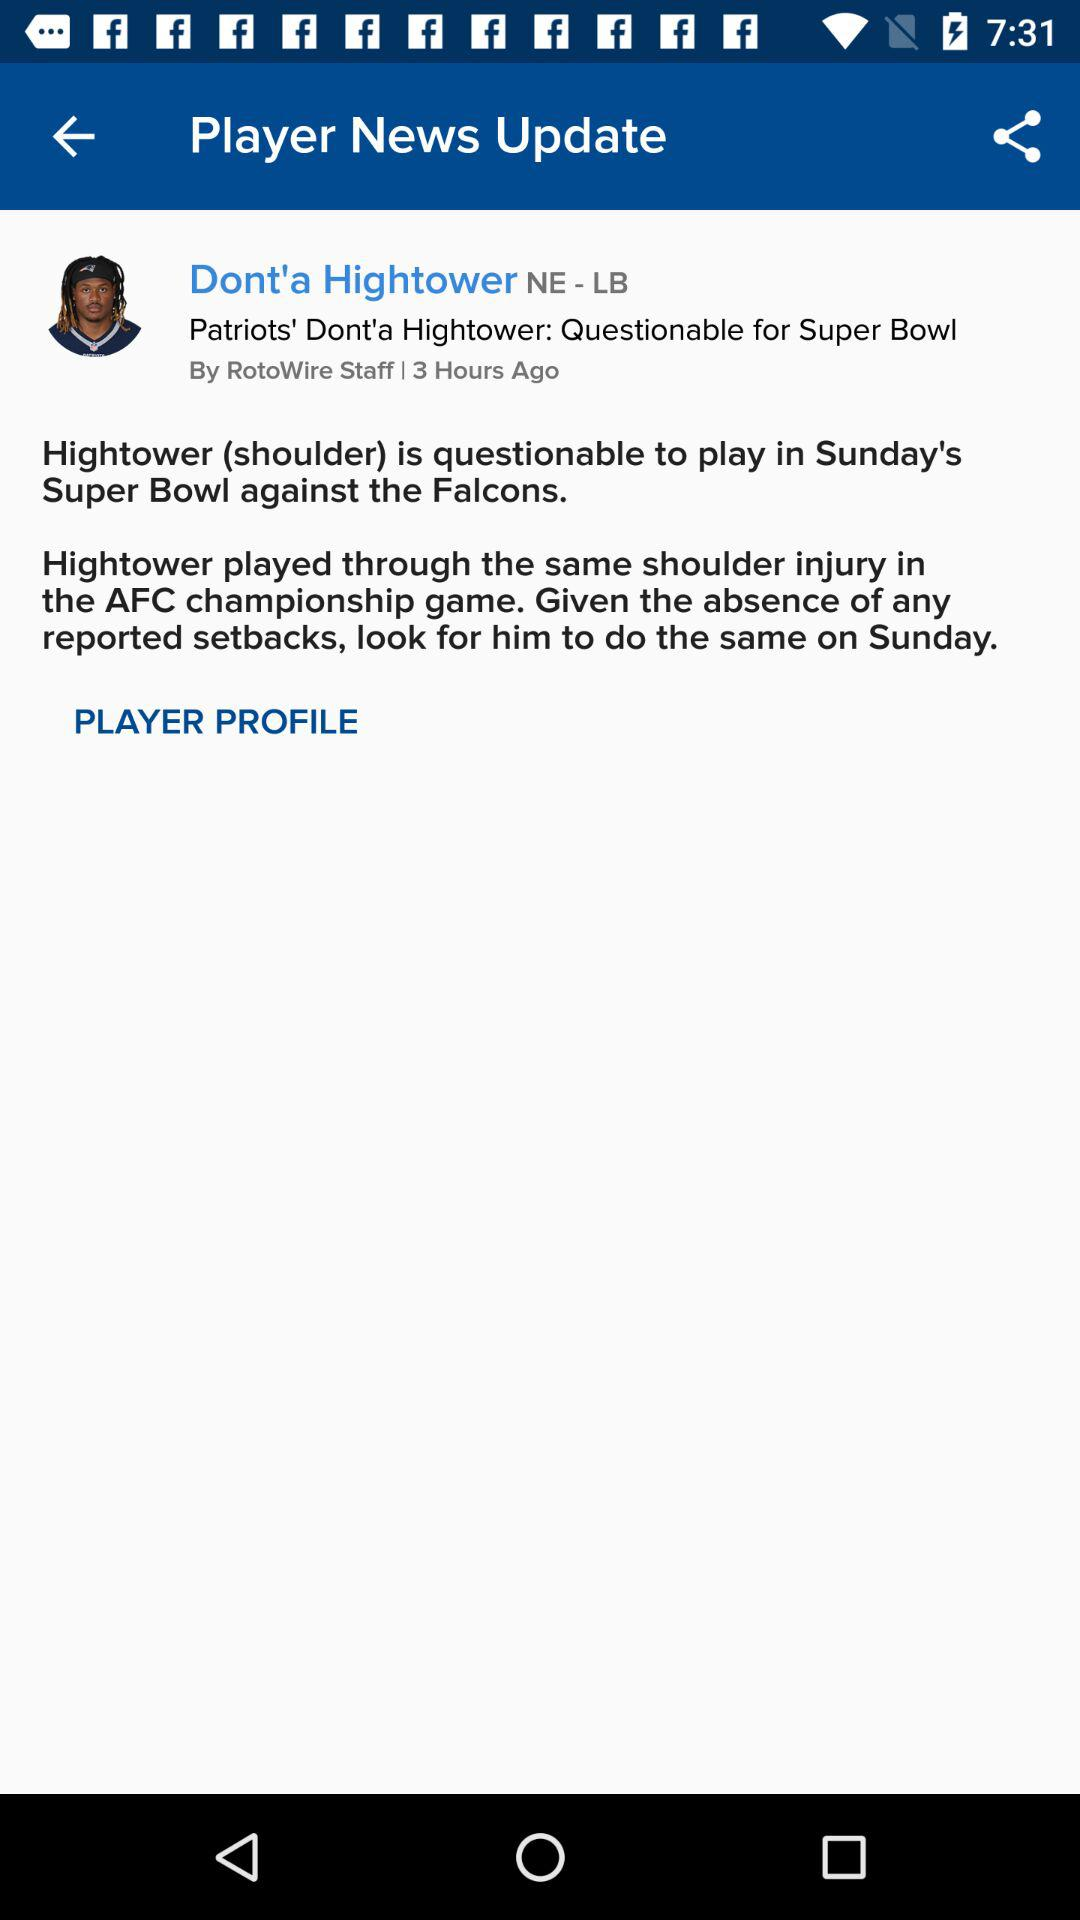When was the news posted? The news was posted 3 hours ago. 